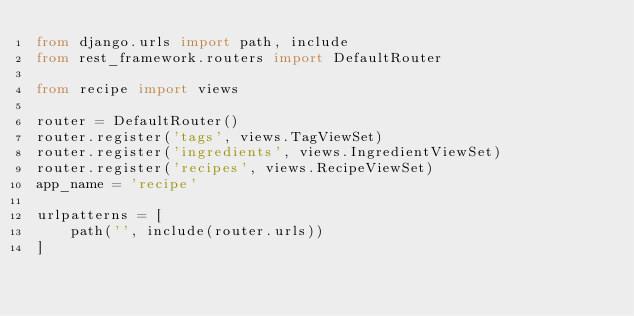<code> <loc_0><loc_0><loc_500><loc_500><_Python_>from django.urls import path, include
from rest_framework.routers import DefaultRouter

from recipe import views

router = DefaultRouter()
router.register('tags', views.TagViewSet)
router.register('ingredients', views.IngredientViewSet)
router.register('recipes', views.RecipeViewSet)
app_name = 'recipe'

urlpatterns = [
    path('', include(router.urls))
]</code> 